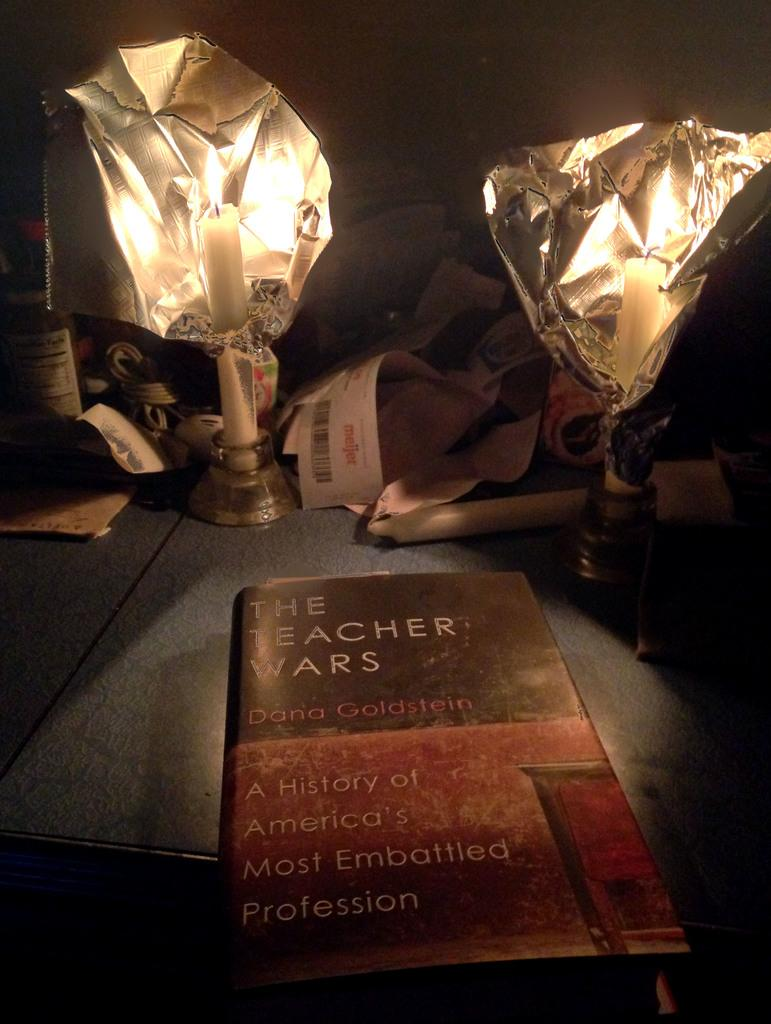<image>
Share a concise interpretation of the image provided. A book about the difficult world of education is titled The Teacher Wars. 